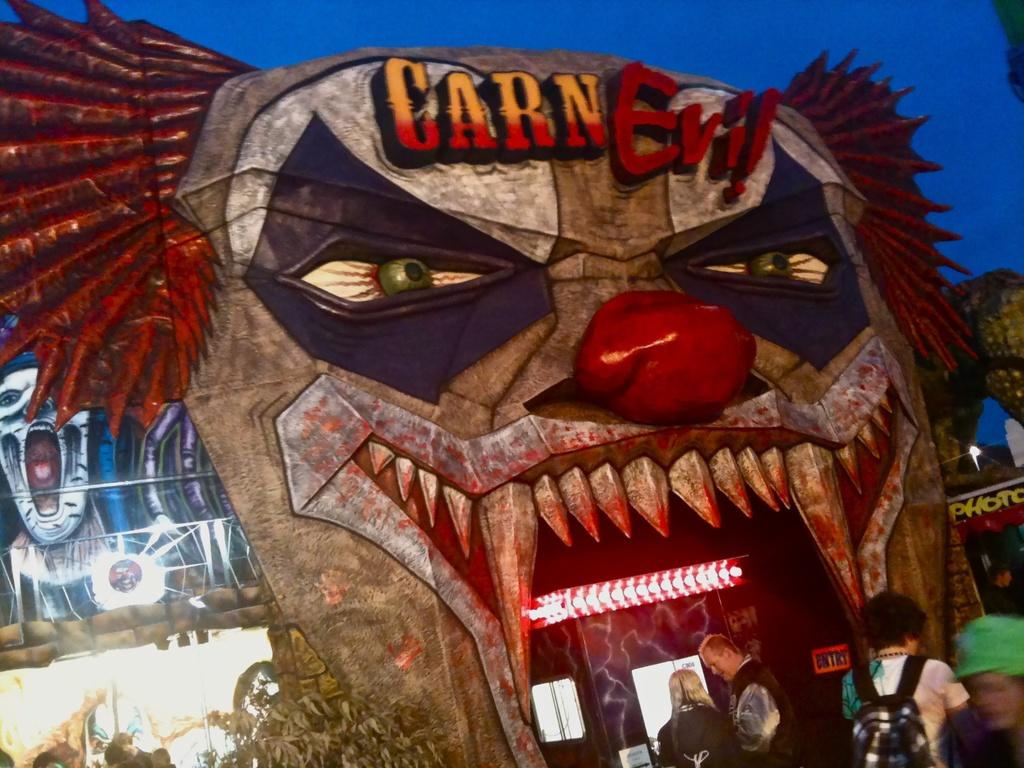What is the main subject in the center of the image? There is an illustration in the center of the image. Can you describe the people in the image? There are people in the image. What type of vegetation is at the bottom of the image? There are plants at the bottom of the image. Where is the sofa located in the image? There is no sofa present in the image. What role does the glue play in the image? There is no glue present in the image, so it does not play any role. 